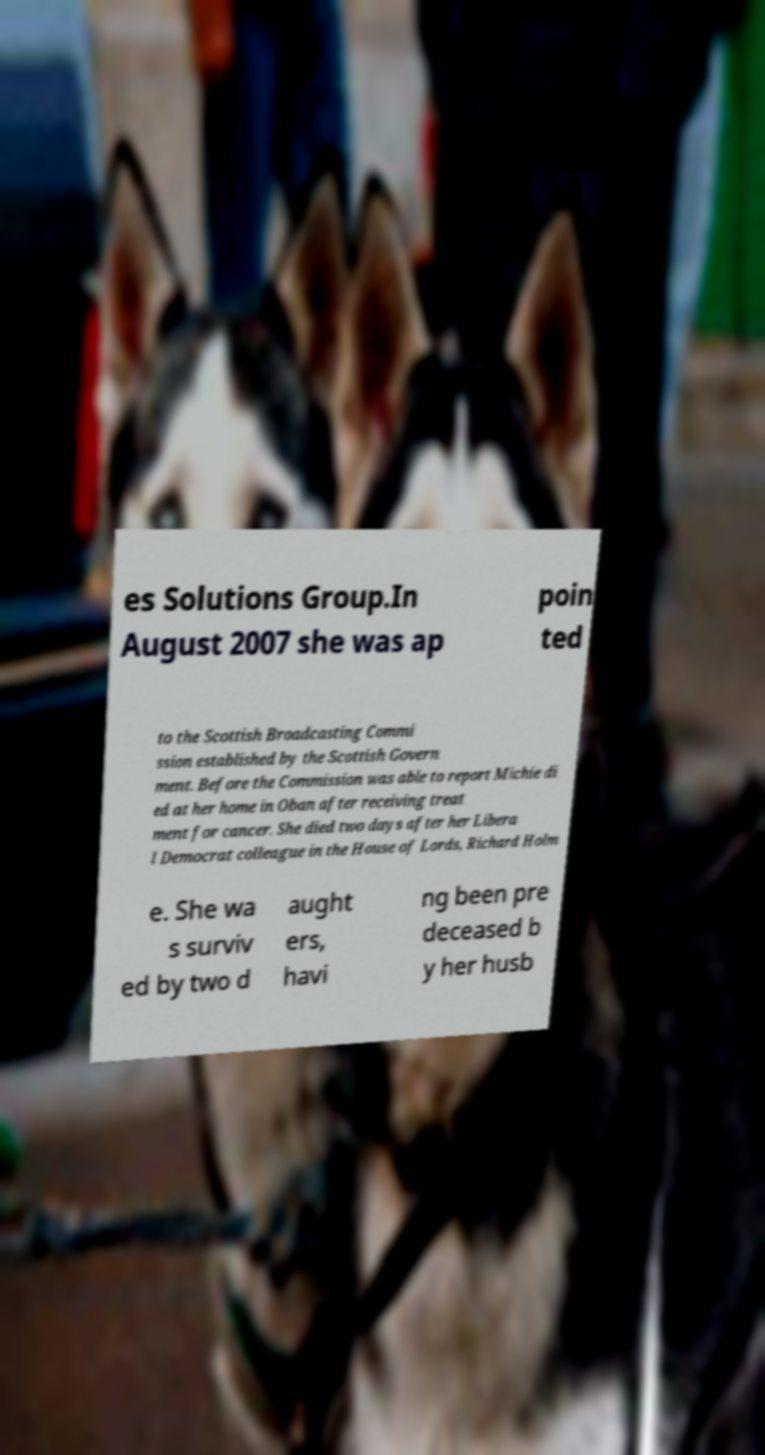I need the written content from this picture converted into text. Can you do that? es Solutions Group.In August 2007 she was ap poin ted to the Scottish Broadcasting Commi ssion established by the Scottish Govern ment. Before the Commission was able to report Michie di ed at her home in Oban after receiving treat ment for cancer. She died two days after her Libera l Democrat colleague in the House of Lords, Richard Holm e. She wa s surviv ed by two d aught ers, havi ng been pre deceased b y her husb 